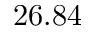Convert formula to latex. <formula><loc_0><loc_0><loc_500><loc_500>2 6 . 8 4</formula> 